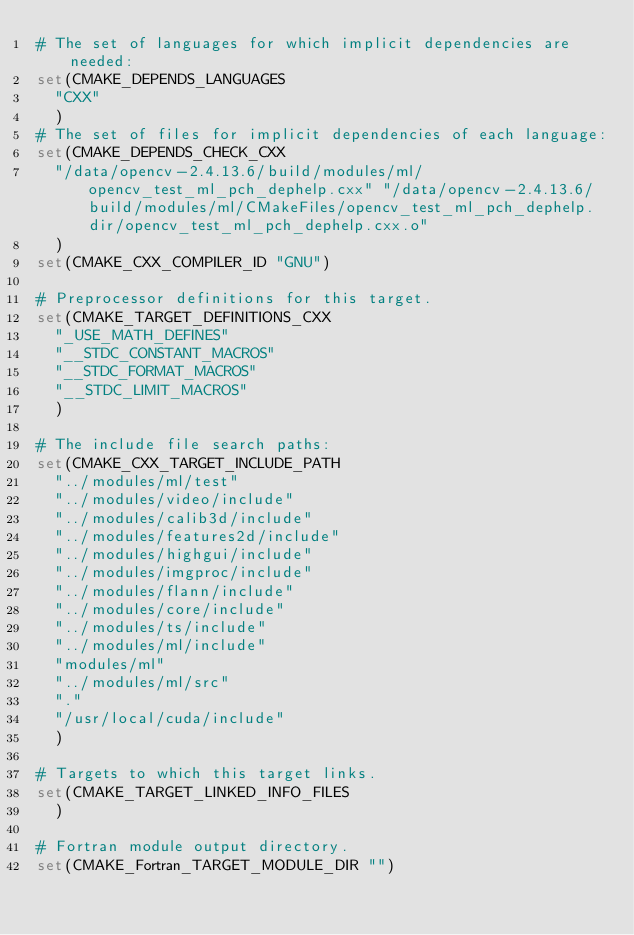<code> <loc_0><loc_0><loc_500><loc_500><_CMake_># The set of languages for which implicit dependencies are needed:
set(CMAKE_DEPENDS_LANGUAGES
  "CXX"
  )
# The set of files for implicit dependencies of each language:
set(CMAKE_DEPENDS_CHECK_CXX
  "/data/opencv-2.4.13.6/build/modules/ml/opencv_test_ml_pch_dephelp.cxx" "/data/opencv-2.4.13.6/build/modules/ml/CMakeFiles/opencv_test_ml_pch_dephelp.dir/opencv_test_ml_pch_dephelp.cxx.o"
  )
set(CMAKE_CXX_COMPILER_ID "GNU")

# Preprocessor definitions for this target.
set(CMAKE_TARGET_DEFINITIONS_CXX
  "_USE_MATH_DEFINES"
  "__STDC_CONSTANT_MACROS"
  "__STDC_FORMAT_MACROS"
  "__STDC_LIMIT_MACROS"
  )

# The include file search paths:
set(CMAKE_CXX_TARGET_INCLUDE_PATH
  "../modules/ml/test"
  "../modules/video/include"
  "../modules/calib3d/include"
  "../modules/features2d/include"
  "../modules/highgui/include"
  "../modules/imgproc/include"
  "../modules/flann/include"
  "../modules/core/include"
  "../modules/ts/include"
  "../modules/ml/include"
  "modules/ml"
  "../modules/ml/src"
  "."
  "/usr/local/cuda/include"
  )

# Targets to which this target links.
set(CMAKE_TARGET_LINKED_INFO_FILES
  )

# Fortran module output directory.
set(CMAKE_Fortran_TARGET_MODULE_DIR "")
</code> 